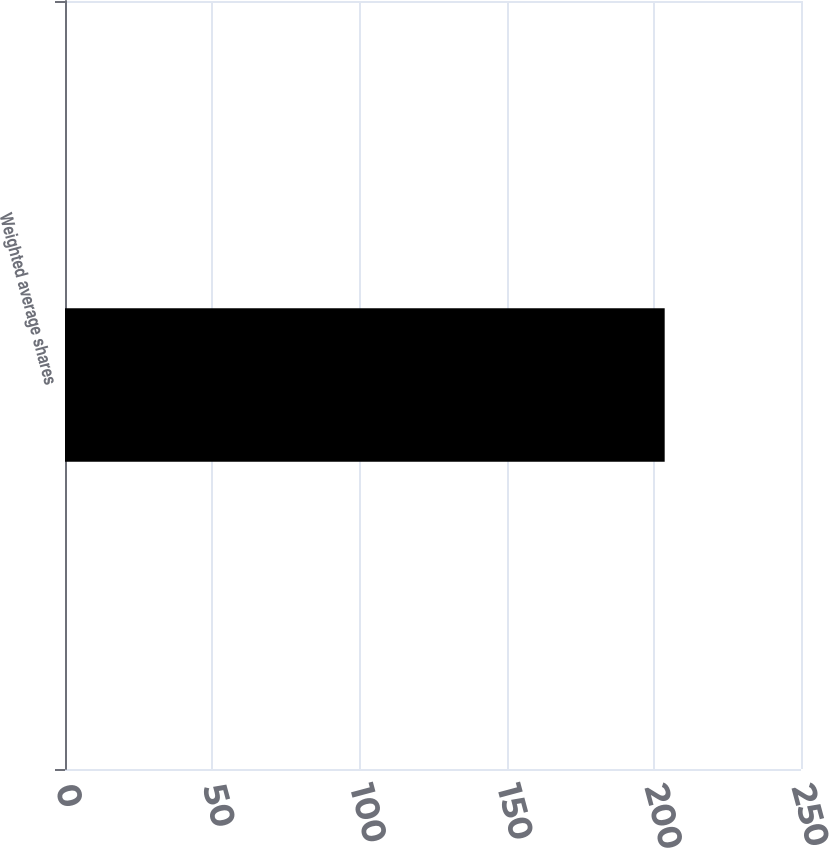<chart> <loc_0><loc_0><loc_500><loc_500><bar_chart><fcel>Weighted average shares<nl><fcel>203.7<nl></chart> 